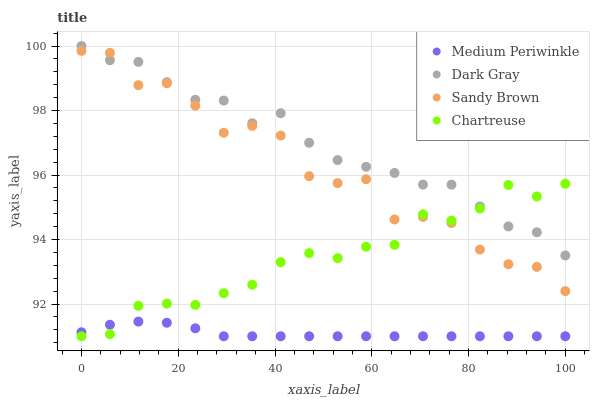Does Medium Periwinkle have the minimum area under the curve?
Answer yes or no. Yes. Does Dark Gray have the maximum area under the curve?
Answer yes or no. Yes. Does Sandy Brown have the minimum area under the curve?
Answer yes or no. No. Does Sandy Brown have the maximum area under the curve?
Answer yes or no. No. Is Medium Periwinkle the smoothest?
Answer yes or no. Yes. Is Sandy Brown the roughest?
Answer yes or no. Yes. Is Chartreuse the smoothest?
Answer yes or no. No. Is Chartreuse the roughest?
Answer yes or no. No. Does Chartreuse have the lowest value?
Answer yes or no. Yes. Does Sandy Brown have the lowest value?
Answer yes or no. No. Does Dark Gray have the highest value?
Answer yes or no. Yes. Does Sandy Brown have the highest value?
Answer yes or no. No. Is Medium Periwinkle less than Dark Gray?
Answer yes or no. Yes. Is Dark Gray greater than Medium Periwinkle?
Answer yes or no. Yes. Does Sandy Brown intersect Chartreuse?
Answer yes or no. Yes. Is Sandy Brown less than Chartreuse?
Answer yes or no. No. Is Sandy Brown greater than Chartreuse?
Answer yes or no. No. Does Medium Periwinkle intersect Dark Gray?
Answer yes or no. No. 